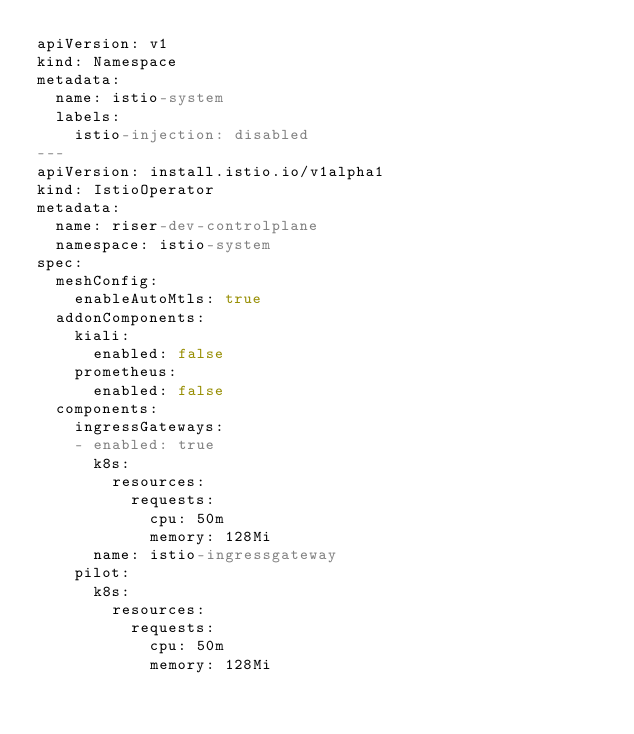Convert code to text. <code><loc_0><loc_0><loc_500><loc_500><_YAML_>apiVersion: v1
kind: Namespace
metadata:
  name: istio-system
  labels:
    istio-injection: disabled
---
apiVersion: install.istio.io/v1alpha1
kind: IstioOperator
metadata:
  name: riser-dev-controlplane
  namespace: istio-system
spec:
  meshConfig:
    enableAutoMtls: true
  addonComponents:
    kiali:
      enabled: false
    prometheus:
      enabled: false
  components:
    ingressGateways:
    - enabled: true
      k8s:
        resources:
          requests:
            cpu: 50m
            memory: 128Mi
      name: istio-ingressgateway
    pilot:
      k8s:
        resources:
          requests:
            cpu: 50m
            memory: 128Mi


</code> 